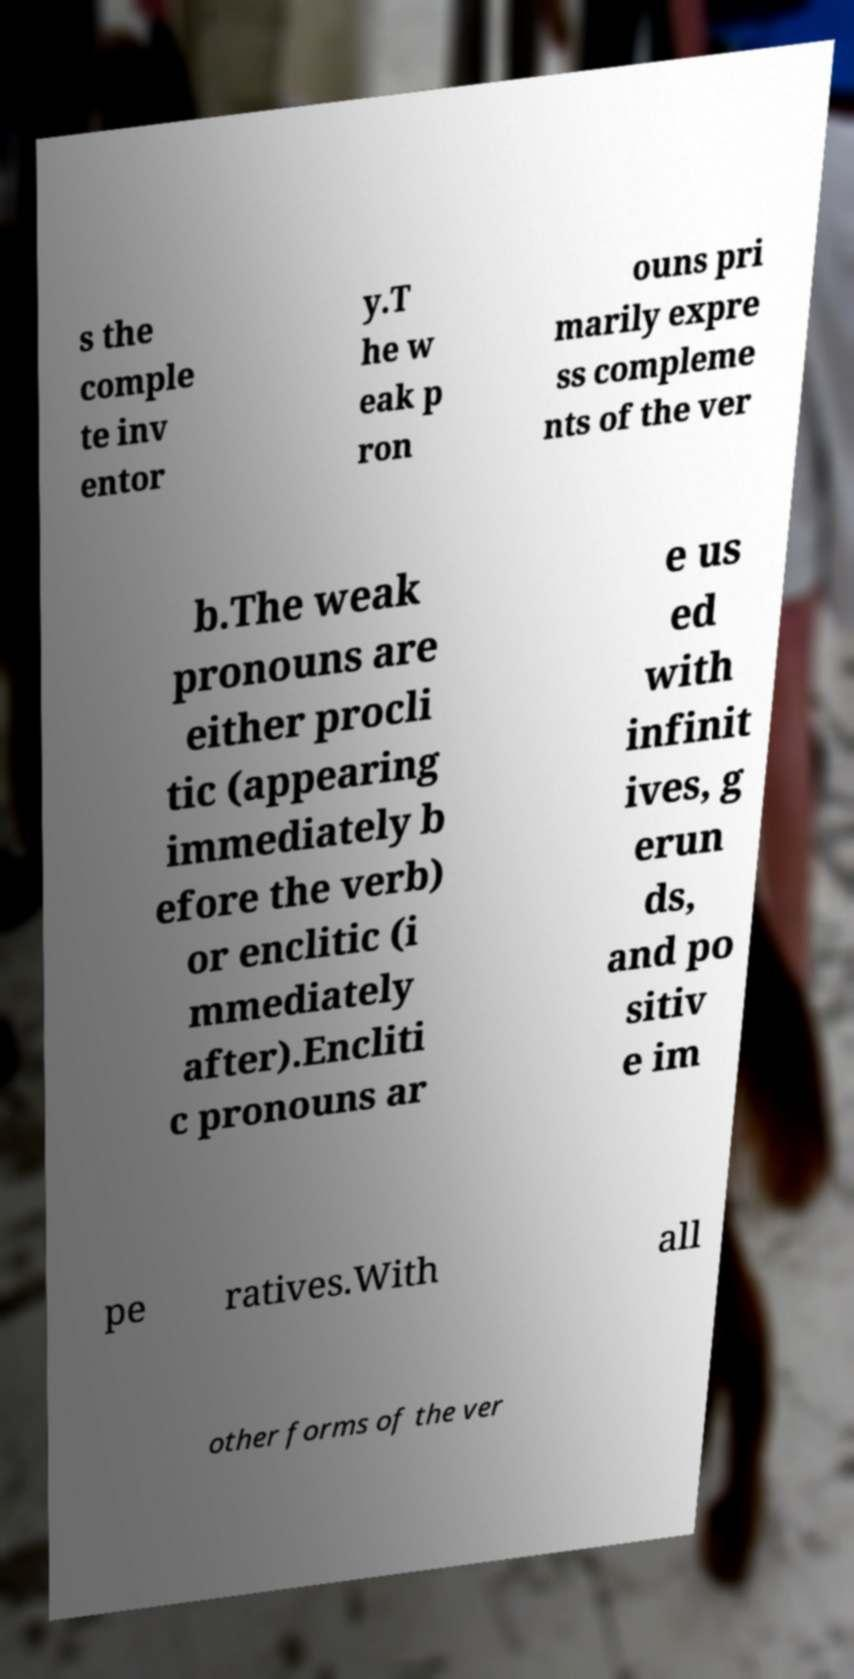There's text embedded in this image that I need extracted. Can you transcribe it verbatim? s the comple te inv entor y.T he w eak p ron ouns pri marily expre ss compleme nts of the ver b.The weak pronouns are either procli tic (appearing immediately b efore the verb) or enclitic (i mmediately after).Encliti c pronouns ar e us ed with infinit ives, g erun ds, and po sitiv e im pe ratives.With all other forms of the ver 